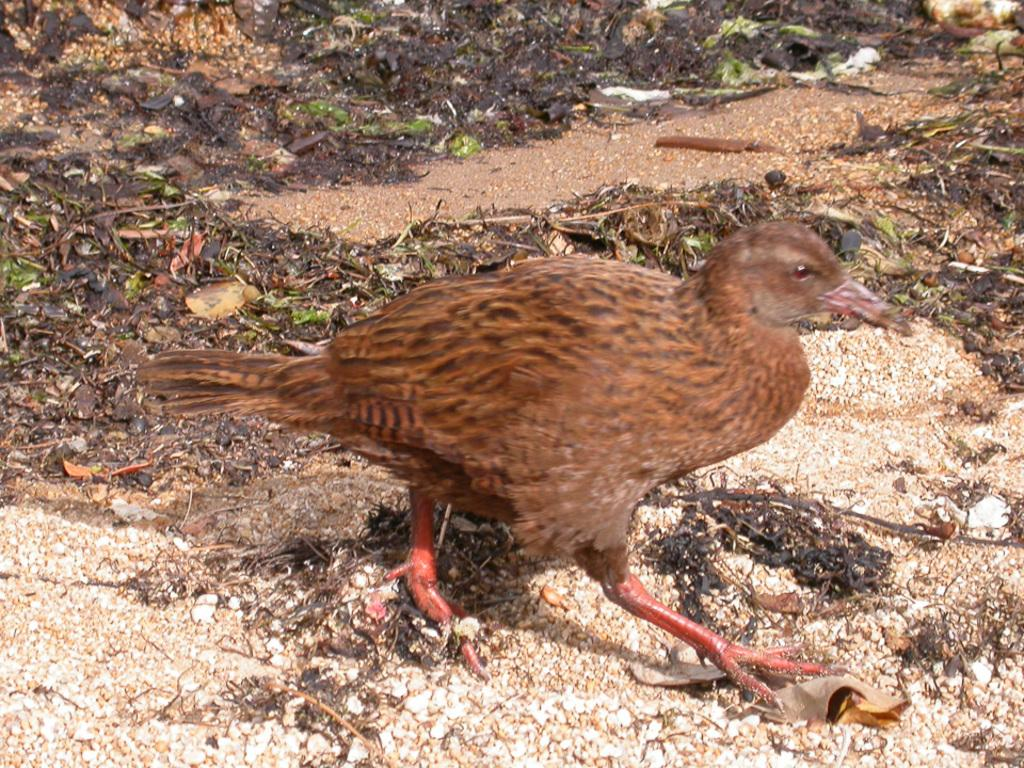What type of animal can be seen in the image? There is a bird in the image. What colors are present on the bird? The bird has brown, red, and black colors. Where is the bird located in the image? The bird is on the ground. What else can be seen on the ground in the image? There are leaves on the ground. What colors are present on the leaves? The leaves have brown, black, and green colors. What type of collar is the bird wearing in the image? There is no collar present on the bird in the image. What color is the orange fruit in the image? There is no orange fruit present in the image. 